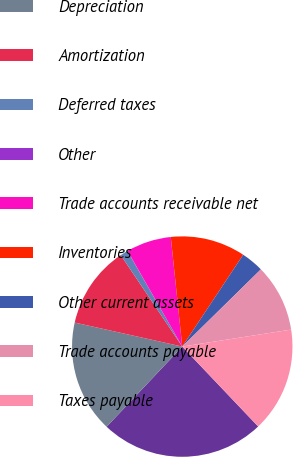Convert chart. <chart><loc_0><loc_0><loc_500><loc_500><pie_chart><fcel>Net earnings<fcel>Depreciation<fcel>Amortization<fcel>Deferred taxes<fcel>Other<fcel>Trade accounts receivable net<fcel>Inventories<fcel>Other current assets<fcel>Trade accounts payable<fcel>Taxes payable<nl><fcel>24.13%<fcel>16.46%<fcel>12.08%<fcel>1.13%<fcel>0.03%<fcel>6.6%<fcel>10.99%<fcel>3.32%<fcel>9.89%<fcel>15.37%<nl></chart> 